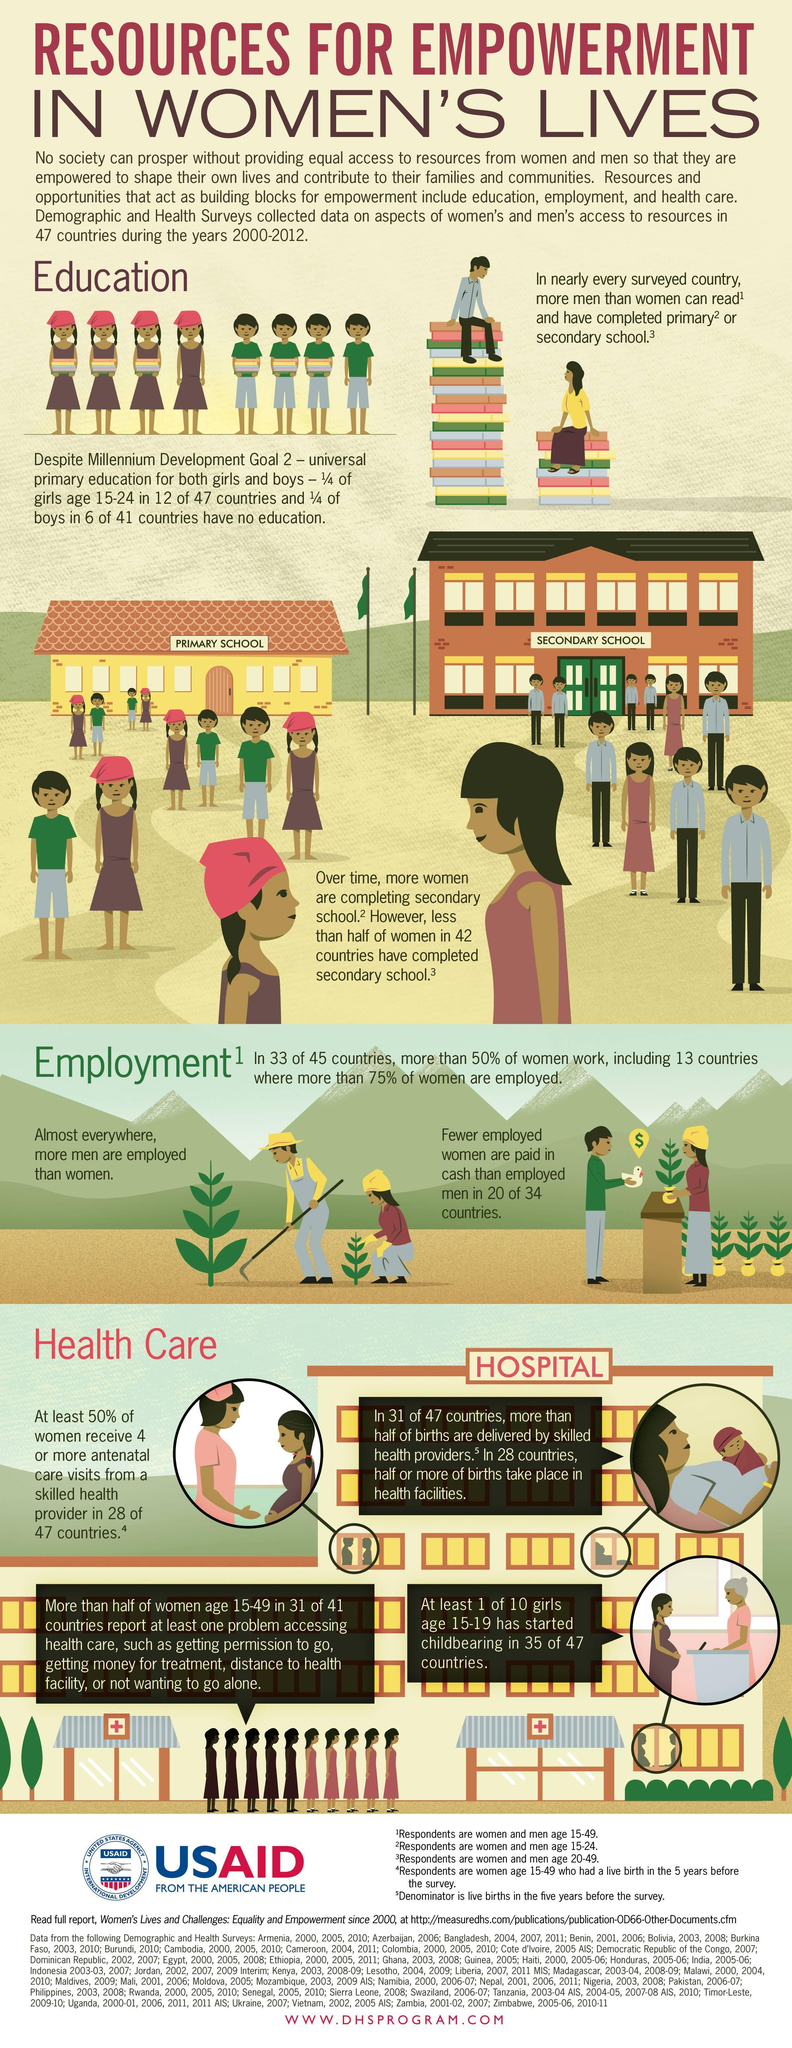How many girls attended primary school out of ten students?
Answer the question with a short phrase. 5 How many girls attended secondary school out of ten students ? 2 What percentage of women between the age 15-49 do not have access to health care? 50% 